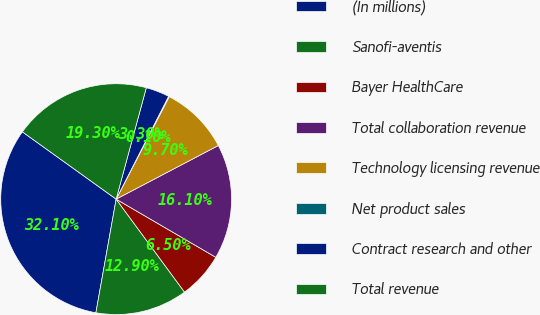Convert chart to OTSL. <chart><loc_0><loc_0><loc_500><loc_500><pie_chart><fcel>(In millions)<fcel>Sanofi-aventis<fcel>Bayer HealthCare<fcel>Total collaboration revenue<fcel>Technology licensing revenue<fcel>Net product sales<fcel>Contract research and other<fcel>Total revenue<nl><fcel>32.1%<fcel>12.9%<fcel>6.5%<fcel>16.1%<fcel>9.7%<fcel>0.1%<fcel>3.3%<fcel>19.3%<nl></chart> 